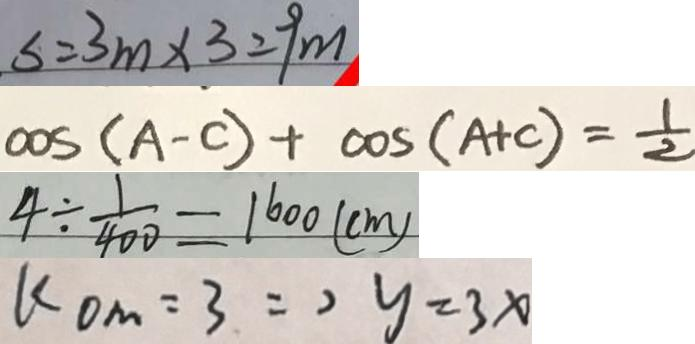<formula> <loc_0><loc_0><loc_500><loc_500>s = 3 m \times 3 = 9 m 
 \cos ( A - C ) + \cos ( A + C ) = \frac { 1 } { 2 } 
 4 \div \frac { 1 } { 4 0 0 } = 1 6 0 0 ( c m ) 
 k O M = 3 \Rightarrow y = 3 x</formula> 